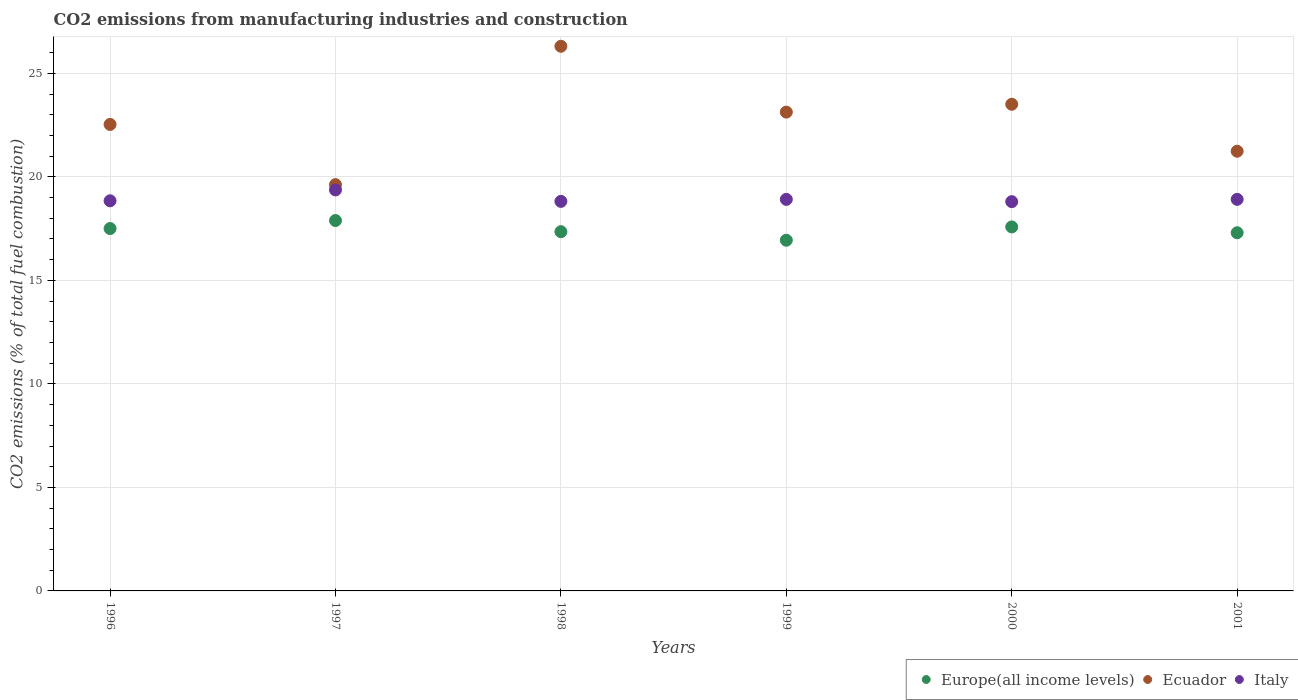How many different coloured dotlines are there?
Offer a very short reply. 3. Is the number of dotlines equal to the number of legend labels?
Offer a terse response. Yes. What is the amount of CO2 emitted in Ecuador in 2000?
Give a very brief answer. 23.51. Across all years, what is the maximum amount of CO2 emitted in Ecuador?
Your response must be concise. 26.31. Across all years, what is the minimum amount of CO2 emitted in Europe(all income levels)?
Ensure brevity in your answer.  16.94. In which year was the amount of CO2 emitted in Ecuador minimum?
Ensure brevity in your answer.  1997. What is the total amount of CO2 emitted in Ecuador in the graph?
Your response must be concise. 136.35. What is the difference between the amount of CO2 emitted in Italy in 1997 and that in 1998?
Provide a succinct answer. 0.55. What is the difference between the amount of CO2 emitted in Europe(all income levels) in 1998 and the amount of CO2 emitted in Ecuador in 1997?
Your answer should be very brief. -2.27. What is the average amount of CO2 emitted in Europe(all income levels) per year?
Provide a succinct answer. 17.43. In the year 1997, what is the difference between the amount of CO2 emitted in Europe(all income levels) and amount of CO2 emitted in Ecuador?
Provide a succinct answer. -1.74. What is the ratio of the amount of CO2 emitted in Europe(all income levels) in 1997 to that in 2000?
Provide a short and direct response. 1.02. What is the difference between the highest and the second highest amount of CO2 emitted in Europe(all income levels)?
Offer a very short reply. 0.31. What is the difference between the highest and the lowest amount of CO2 emitted in Italy?
Provide a succinct answer. 0.57. Is it the case that in every year, the sum of the amount of CO2 emitted in Europe(all income levels) and amount of CO2 emitted in Italy  is greater than the amount of CO2 emitted in Ecuador?
Offer a terse response. Yes. Is the amount of CO2 emitted in Italy strictly less than the amount of CO2 emitted in Europe(all income levels) over the years?
Your answer should be very brief. No. What is the difference between two consecutive major ticks on the Y-axis?
Your response must be concise. 5. Does the graph contain any zero values?
Make the answer very short. No. How many legend labels are there?
Keep it short and to the point. 3. What is the title of the graph?
Give a very brief answer. CO2 emissions from manufacturing industries and construction. What is the label or title of the X-axis?
Provide a succinct answer. Years. What is the label or title of the Y-axis?
Your response must be concise. CO2 emissions (% of total fuel combustion). What is the CO2 emissions (% of total fuel combustion) in Europe(all income levels) in 1996?
Give a very brief answer. 17.51. What is the CO2 emissions (% of total fuel combustion) in Ecuador in 1996?
Your response must be concise. 22.53. What is the CO2 emissions (% of total fuel combustion) of Italy in 1996?
Your response must be concise. 18.84. What is the CO2 emissions (% of total fuel combustion) of Europe(all income levels) in 1997?
Ensure brevity in your answer.  17.89. What is the CO2 emissions (% of total fuel combustion) of Ecuador in 1997?
Offer a very short reply. 19.63. What is the CO2 emissions (% of total fuel combustion) of Italy in 1997?
Your answer should be compact. 19.37. What is the CO2 emissions (% of total fuel combustion) in Europe(all income levels) in 1998?
Offer a very short reply. 17.35. What is the CO2 emissions (% of total fuel combustion) in Ecuador in 1998?
Your answer should be compact. 26.31. What is the CO2 emissions (% of total fuel combustion) in Italy in 1998?
Your answer should be very brief. 18.82. What is the CO2 emissions (% of total fuel combustion) in Europe(all income levels) in 1999?
Provide a succinct answer. 16.94. What is the CO2 emissions (% of total fuel combustion) of Ecuador in 1999?
Your response must be concise. 23.13. What is the CO2 emissions (% of total fuel combustion) of Italy in 1999?
Ensure brevity in your answer.  18.91. What is the CO2 emissions (% of total fuel combustion) of Europe(all income levels) in 2000?
Keep it short and to the point. 17.58. What is the CO2 emissions (% of total fuel combustion) of Ecuador in 2000?
Ensure brevity in your answer.  23.51. What is the CO2 emissions (% of total fuel combustion) in Italy in 2000?
Your answer should be very brief. 18.8. What is the CO2 emissions (% of total fuel combustion) in Europe(all income levels) in 2001?
Make the answer very short. 17.3. What is the CO2 emissions (% of total fuel combustion) of Ecuador in 2001?
Offer a terse response. 21.24. What is the CO2 emissions (% of total fuel combustion) in Italy in 2001?
Your response must be concise. 18.91. Across all years, what is the maximum CO2 emissions (% of total fuel combustion) of Europe(all income levels)?
Provide a succinct answer. 17.89. Across all years, what is the maximum CO2 emissions (% of total fuel combustion) in Ecuador?
Provide a succinct answer. 26.31. Across all years, what is the maximum CO2 emissions (% of total fuel combustion) of Italy?
Give a very brief answer. 19.37. Across all years, what is the minimum CO2 emissions (% of total fuel combustion) in Europe(all income levels)?
Offer a terse response. 16.94. Across all years, what is the minimum CO2 emissions (% of total fuel combustion) of Ecuador?
Offer a terse response. 19.63. Across all years, what is the minimum CO2 emissions (% of total fuel combustion) in Italy?
Your answer should be very brief. 18.8. What is the total CO2 emissions (% of total fuel combustion) of Europe(all income levels) in the graph?
Make the answer very short. 104.57. What is the total CO2 emissions (% of total fuel combustion) of Ecuador in the graph?
Make the answer very short. 136.35. What is the total CO2 emissions (% of total fuel combustion) in Italy in the graph?
Offer a very short reply. 113.66. What is the difference between the CO2 emissions (% of total fuel combustion) of Europe(all income levels) in 1996 and that in 1997?
Your response must be concise. -0.39. What is the difference between the CO2 emissions (% of total fuel combustion) in Ecuador in 1996 and that in 1997?
Offer a very short reply. 2.91. What is the difference between the CO2 emissions (% of total fuel combustion) in Italy in 1996 and that in 1997?
Your answer should be compact. -0.52. What is the difference between the CO2 emissions (% of total fuel combustion) of Europe(all income levels) in 1996 and that in 1998?
Make the answer very short. 0.15. What is the difference between the CO2 emissions (% of total fuel combustion) in Ecuador in 1996 and that in 1998?
Offer a very short reply. -3.78. What is the difference between the CO2 emissions (% of total fuel combustion) of Italy in 1996 and that in 1998?
Give a very brief answer. 0.03. What is the difference between the CO2 emissions (% of total fuel combustion) of Europe(all income levels) in 1996 and that in 1999?
Keep it short and to the point. 0.56. What is the difference between the CO2 emissions (% of total fuel combustion) of Ecuador in 1996 and that in 1999?
Ensure brevity in your answer.  -0.6. What is the difference between the CO2 emissions (% of total fuel combustion) in Italy in 1996 and that in 1999?
Your response must be concise. -0.07. What is the difference between the CO2 emissions (% of total fuel combustion) of Europe(all income levels) in 1996 and that in 2000?
Give a very brief answer. -0.08. What is the difference between the CO2 emissions (% of total fuel combustion) of Ecuador in 1996 and that in 2000?
Keep it short and to the point. -0.97. What is the difference between the CO2 emissions (% of total fuel combustion) in Italy in 1996 and that in 2000?
Give a very brief answer. 0.04. What is the difference between the CO2 emissions (% of total fuel combustion) of Europe(all income levels) in 1996 and that in 2001?
Ensure brevity in your answer.  0.2. What is the difference between the CO2 emissions (% of total fuel combustion) of Ecuador in 1996 and that in 2001?
Make the answer very short. 1.29. What is the difference between the CO2 emissions (% of total fuel combustion) in Italy in 1996 and that in 2001?
Your answer should be compact. -0.07. What is the difference between the CO2 emissions (% of total fuel combustion) of Europe(all income levels) in 1997 and that in 1998?
Provide a short and direct response. 0.54. What is the difference between the CO2 emissions (% of total fuel combustion) of Ecuador in 1997 and that in 1998?
Your answer should be very brief. -6.68. What is the difference between the CO2 emissions (% of total fuel combustion) in Italy in 1997 and that in 1998?
Your response must be concise. 0.55. What is the difference between the CO2 emissions (% of total fuel combustion) in Europe(all income levels) in 1997 and that in 1999?
Offer a terse response. 0.95. What is the difference between the CO2 emissions (% of total fuel combustion) in Ecuador in 1997 and that in 1999?
Your response must be concise. -3.5. What is the difference between the CO2 emissions (% of total fuel combustion) in Italy in 1997 and that in 1999?
Offer a terse response. 0.46. What is the difference between the CO2 emissions (% of total fuel combustion) in Europe(all income levels) in 1997 and that in 2000?
Your response must be concise. 0.31. What is the difference between the CO2 emissions (% of total fuel combustion) in Ecuador in 1997 and that in 2000?
Your response must be concise. -3.88. What is the difference between the CO2 emissions (% of total fuel combustion) of Italy in 1997 and that in 2000?
Offer a very short reply. 0.57. What is the difference between the CO2 emissions (% of total fuel combustion) of Europe(all income levels) in 1997 and that in 2001?
Your response must be concise. 0.59. What is the difference between the CO2 emissions (% of total fuel combustion) in Ecuador in 1997 and that in 2001?
Give a very brief answer. -1.61. What is the difference between the CO2 emissions (% of total fuel combustion) of Italy in 1997 and that in 2001?
Offer a terse response. 0.46. What is the difference between the CO2 emissions (% of total fuel combustion) of Europe(all income levels) in 1998 and that in 1999?
Give a very brief answer. 0.41. What is the difference between the CO2 emissions (% of total fuel combustion) of Ecuador in 1998 and that in 1999?
Your answer should be very brief. 3.18. What is the difference between the CO2 emissions (% of total fuel combustion) of Italy in 1998 and that in 1999?
Offer a terse response. -0.1. What is the difference between the CO2 emissions (% of total fuel combustion) of Europe(all income levels) in 1998 and that in 2000?
Your answer should be compact. -0.23. What is the difference between the CO2 emissions (% of total fuel combustion) in Ecuador in 1998 and that in 2000?
Provide a short and direct response. 2.8. What is the difference between the CO2 emissions (% of total fuel combustion) of Italy in 1998 and that in 2000?
Provide a succinct answer. 0.01. What is the difference between the CO2 emissions (% of total fuel combustion) in Europe(all income levels) in 1998 and that in 2001?
Your response must be concise. 0.05. What is the difference between the CO2 emissions (% of total fuel combustion) of Ecuador in 1998 and that in 2001?
Keep it short and to the point. 5.07. What is the difference between the CO2 emissions (% of total fuel combustion) of Italy in 1998 and that in 2001?
Your answer should be very brief. -0.1. What is the difference between the CO2 emissions (% of total fuel combustion) of Europe(all income levels) in 1999 and that in 2000?
Offer a terse response. -0.64. What is the difference between the CO2 emissions (% of total fuel combustion) of Ecuador in 1999 and that in 2000?
Provide a succinct answer. -0.38. What is the difference between the CO2 emissions (% of total fuel combustion) in Italy in 1999 and that in 2000?
Offer a terse response. 0.11. What is the difference between the CO2 emissions (% of total fuel combustion) of Europe(all income levels) in 1999 and that in 2001?
Provide a short and direct response. -0.36. What is the difference between the CO2 emissions (% of total fuel combustion) in Ecuador in 1999 and that in 2001?
Ensure brevity in your answer.  1.89. What is the difference between the CO2 emissions (% of total fuel combustion) of Italy in 1999 and that in 2001?
Offer a very short reply. -0. What is the difference between the CO2 emissions (% of total fuel combustion) of Europe(all income levels) in 2000 and that in 2001?
Give a very brief answer. 0.28. What is the difference between the CO2 emissions (% of total fuel combustion) of Ecuador in 2000 and that in 2001?
Make the answer very short. 2.27. What is the difference between the CO2 emissions (% of total fuel combustion) of Italy in 2000 and that in 2001?
Offer a very short reply. -0.11. What is the difference between the CO2 emissions (% of total fuel combustion) in Europe(all income levels) in 1996 and the CO2 emissions (% of total fuel combustion) in Ecuador in 1997?
Make the answer very short. -2.12. What is the difference between the CO2 emissions (% of total fuel combustion) of Europe(all income levels) in 1996 and the CO2 emissions (% of total fuel combustion) of Italy in 1997?
Ensure brevity in your answer.  -1.86. What is the difference between the CO2 emissions (% of total fuel combustion) in Ecuador in 1996 and the CO2 emissions (% of total fuel combustion) in Italy in 1997?
Provide a short and direct response. 3.16. What is the difference between the CO2 emissions (% of total fuel combustion) in Europe(all income levels) in 1996 and the CO2 emissions (% of total fuel combustion) in Ecuador in 1998?
Your answer should be compact. -8.8. What is the difference between the CO2 emissions (% of total fuel combustion) in Europe(all income levels) in 1996 and the CO2 emissions (% of total fuel combustion) in Italy in 1998?
Give a very brief answer. -1.31. What is the difference between the CO2 emissions (% of total fuel combustion) of Ecuador in 1996 and the CO2 emissions (% of total fuel combustion) of Italy in 1998?
Your answer should be compact. 3.72. What is the difference between the CO2 emissions (% of total fuel combustion) of Europe(all income levels) in 1996 and the CO2 emissions (% of total fuel combustion) of Ecuador in 1999?
Your answer should be compact. -5.62. What is the difference between the CO2 emissions (% of total fuel combustion) in Europe(all income levels) in 1996 and the CO2 emissions (% of total fuel combustion) in Italy in 1999?
Your answer should be very brief. -1.41. What is the difference between the CO2 emissions (% of total fuel combustion) in Ecuador in 1996 and the CO2 emissions (% of total fuel combustion) in Italy in 1999?
Your answer should be compact. 3.62. What is the difference between the CO2 emissions (% of total fuel combustion) in Europe(all income levels) in 1996 and the CO2 emissions (% of total fuel combustion) in Ecuador in 2000?
Offer a terse response. -6. What is the difference between the CO2 emissions (% of total fuel combustion) of Europe(all income levels) in 1996 and the CO2 emissions (% of total fuel combustion) of Italy in 2000?
Offer a terse response. -1.3. What is the difference between the CO2 emissions (% of total fuel combustion) of Ecuador in 1996 and the CO2 emissions (% of total fuel combustion) of Italy in 2000?
Keep it short and to the point. 3.73. What is the difference between the CO2 emissions (% of total fuel combustion) of Europe(all income levels) in 1996 and the CO2 emissions (% of total fuel combustion) of Ecuador in 2001?
Provide a short and direct response. -3.73. What is the difference between the CO2 emissions (% of total fuel combustion) of Europe(all income levels) in 1996 and the CO2 emissions (% of total fuel combustion) of Italy in 2001?
Your response must be concise. -1.41. What is the difference between the CO2 emissions (% of total fuel combustion) in Ecuador in 1996 and the CO2 emissions (% of total fuel combustion) in Italy in 2001?
Give a very brief answer. 3.62. What is the difference between the CO2 emissions (% of total fuel combustion) of Europe(all income levels) in 1997 and the CO2 emissions (% of total fuel combustion) of Ecuador in 1998?
Offer a terse response. -8.42. What is the difference between the CO2 emissions (% of total fuel combustion) in Europe(all income levels) in 1997 and the CO2 emissions (% of total fuel combustion) in Italy in 1998?
Ensure brevity in your answer.  -0.93. What is the difference between the CO2 emissions (% of total fuel combustion) in Ecuador in 1997 and the CO2 emissions (% of total fuel combustion) in Italy in 1998?
Offer a very short reply. 0.81. What is the difference between the CO2 emissions (% of total fuel combustion) in Europe(all income levels) in 1997 and the CO2 emissions (% of total fuel combustion) in Ecuador in 1999?
Give a very brief answer. -5.24. What is the difference between the CO2 emissions (% of total fuel combustion) in Europe(all income levels) in 1997 and the CO2 emissions (% of total fuel combustion) in Italy in 1999?
Provide a short and direct response. -1.02. What is the difference between the CO2 emissions (% of total fuel combustion) of Ecuador in 1997 and the CO2 emissions (% of total fuel combustion) of Italy in 1999?
Ensure brevity in your answer.  0.71. What is the difference between the CO2 emissions (% of total fuel combustion) in Europe(all income levels) in 1997 and the CO2 emissions (% of total fuel combustion) in Ecuador in 2000?
Make the answer very short. -5.62. What is the difference between the CO2 emissions (% of total fuel combustion) of Europe(all income levels) in 1997 and the CO2 emissions (% of total fuel combustion) of Italy in 2000?
Your answer should be compact. -0.91. What is the difference between the CO2 emissions (% of total fuel combustion) of Ecuador in 1997 and the CO2 emissions (% of total fuel combustion) of Italy in 2000?
Your response must be concise. 0.82. What is the difference between the CO2 emissions (% of total fuel combustion) of Europe(all income levels) in 1997 and the CO2 emissions (% of total fuel combustion) of Ecuador in 2001?
Your answer should be very brief. -3.35. What is the difference between the CO2 emissions (% of total fuel combustion) of Europe(all income levels) in 1997 and the CO2 emissions (% of total fuel combustion) of Italy in 2001?
Make the answer very short. -1.02. What is the difference between the CO2 emissions (% of total fuel combustion) in Ecuador in 1997 and the CO2 emissions (% of total fuel combustion) in Italy in 2001?
Provide a short and direct response. 0.71. What is the difference between the CO2 emissions (% of total fuel combustion) in Europe(all income levels) in 1998 and the CO2 emissions (% of total fuel combustion) in Ecuador in 1999?
Provide a succinct answer. -5.78. What is the difference between the CO2 emissions (% of total fuel combustion) of Europe(all income levels) in 1998 and the CO2 emissions (% of total fuel combustion) of Italy in 1999?
Keep it short and to the point. -1.56. What is the difference between the CO2 emissions (% of total fuel combustion) of Ecuador in 1998 and the CO2 emissions (% of total fuel combustion) of Italy in 1999?
Keep it short and to the point. 7.4. What is the difference between the CO2 emissions (% of total fuel combustion) of Europe(all income levels) in 1998 and the CO2 emissions (% of total fuel combustion) of Ecuador in 2000?
Your answer should be compact. -6.16. What is the difference between the CO2 emissions (% of total fuel combustion) of Europe(all income levels) in 1998 and the CO2 emissions (% of total fuel combustion) of Italy in 2000?
Your answer should be very brief. -1.45. What is the difference between the CO2 emissions (% of total fuel combustion) of Ecuador in 1998 and the CO2 emissions (% of total fuel combustion) of Italy in 2000?
Your response must be concise. 7.51. What is the difference between the CO2 emissions (% of total fuel combustion) in Europe(all income levels) in 1998 and the CO2 emissions (% of total fuel combustion) in Ecuador in 2001?
Your response must be concise. -3.89. What is the difference between the CO2 emissions (% of total fuel combustion) of Europe(all income levels) in 1998 and the CO2 emissions (% of total fuel combustion) of Italy in 2001?
Make the answer very short. -1.56. What is the difference between the CO2 emissions (% of total fuel combustion) in Ecuador in 1998 and the CO2 emissions (% of total fuel combustion) in Italy in 2001?
Give a very brief answer. 7.39. What is the difference between the CO2 emissions (% of total fuel combustion) of Europe(all income levels) in 1999 and the CO2 emissions (% of total fuel combustion) of Ecuador in 2000?
Ensure brevity in your answer.  -6.57. What is the difference between the CO2 emissions (% of total fuel combustion) in Europe(all income levels) in 1999 and the CO2 emissions (% of total fuel combustion) in Italy in 2000?
Offer a very short reply. -1.86. What is the difference between the CO2 emissions (% of total fuel combustion) in Ecuador in 1999 and the CO2 emissions (% of total fuel combustion) in Italy in 2000?
Your answer should be compact. 4.33. What is the difference between the CO2 emissions (% of total fuel combustion) of Europe(all income levels) in 1999 and the CO2 emissions (% of total fuel combustion) of Ecuador in 2001?
Offer a terse response. -4.3. What is the difference between the CO2 emissions (% of total fuel combustion) in Europe(all income levels) in 1999 and the CO2 emissions (% of total fuel combustion) in Italy in 2001?
Make the answer very short. -1.97. What is the difference between the CO2 emissions (% of total fuel combustion) in Ecuador in 1999 and the CO2 emissions (% of total fuel combustion) in Italy in 2001?
Your answer should be compact. 4.21. What is the difference between the CO2 emissions (% of total fuel combustion) of Europe(all income levels) in 2000 and the CO2 emissions (% of total fuel combustion) of Ecuador in 2001?
Your answer should be compact. -3.66. What is the difference between the CO2 emissions (% of total fuel combustion) of Europe(all income levels) in 2000 and the CO2 emissions (% of total fuel combustion) of Italy in 2001?
Ensure brevity in your answer.  -1.33. What is the difference between the CO2 emissions (% of total fuel combustion) of Ecuador in 2000 and the CO2 emissions (% of total fuel combustion) of Italy in 2001?
Give a very brief answer. 4.59. What is the average CO2 emissions (% of total fuel combustion) of Europe(all income levels) per year?
Provide a succinct answer. 17.43. What is the average CO2 emissions (% of total fuel combustion) of Ecuador per year?
Offer a terse response. 22.72. What is the average CO2 emissions (% of total fuel combustion) of Italy per year?
Offer a very short reply. 18.94. In the year 1996, what is the difference between the CO2 emissions (% of total fuel combustion) of Europe(all income levels) and CO2 emissions (% of total fuel combustion) of Ecuador?
Your answer should be very brief. -5.03. In the year 1996, what is the difference between the CO2 emissions (% of total fuel combustion) in Europe(all income levels) and CO2 emissions (% of total fuel combustion) in Italy?
Your response must be concise. -1.34. In the year 1996, what is the difference between the CO2 emissions (% of total fuel combustion) in Ecuador and CO2 emissions (% of total fuel combustion) in Italy?
Your answer should be very brief. 3.69. In the year 1997, what is the difference between the CO2 emissions (% of total fuel combustion) of Europe(all income levels) and CO2 emissions (% of total fuel combustion) of Ecuador?
Provide a short and direct response. -1.74. In the year 1997, what is the difference between the CO2 emissions (% of total fuel combustion) in Europe(all income levels) and CO2 emissions (% of total fuel combustion) in Italy?
Give a very brief answer. -1.48. In the year 1997, what is the difference between the CO2 emissions (% of total fuel combustion) of Ecuador and CO2 emissions (% of total fuel combustion) of Italy?
Make the answer very short. 0.26. In the year 1998, what is the difference between the CO2 emissions (% of total fuel combustion) in Europe(all income levels) and CO2 emissions (% of total fuel combustion) in Ecuador?
Your answer should be compact. -8.96. In the year 1998, what is the difference between the CO2 emissions (% of total fuel combustion) in Europe(all income levels) and CO2 emissions (% of total fuel combustion) in Italy?
Provide a succinct answer. -1.46. In the year 1998, what is the difference between the CO2 emissions (% of total fuel combustion) in Ecuador and CO2 emissions (% of total fuel combustion) in Italy?
Offer a very short reply. 7.49. In the year 1999, what is the difference between the CO2 emissions (% of total fuel combustion) in Europe(all income levels) and CO2 emissions (% of total fuel combustion) in Ecuador?
Your answer should be compact. -6.19. In the year 1999, what is the difference between the CO2 emissions (% of total fuel combustion) in Europe(all income levels) and CO2 emissions (% of total fuel combustion) in Italy?
Your answer should be very brief. -1.97. In the year 1999, what is the difference between the CO2 emissions (% of total fuel combustion) of Ecuador and CO2 emissions (% of total fuel combustion) of Italy?
Offer a terse response. 4.22. In the year 2000, what is the difference between the CO2 emissions (% of total fuel combustion) in Europe(all income levels) and CO2 emissions (% of total fuel combustion) in Ecuador?
Make the answer very short. -5.93. In the year 2000, what is the difference between the CO2 emissions (% of total fuel combustion) in Europe(all income levels) and CO2 emissions (% of total fuel combustion) in Italy?
Your answer should be compact. -1.22. In the year 2000, what is the difference between the CO2 emissions (% of total fuel combustion) in Ecuador and CO2 emissions (% of total fuel combustion) in Italy?
Give a very brief answer. 4.7. In the year 2001, what is the difference between the CO2 emissions (% of total fuel combustion) in Europe(all income levels) and CO2 emissions (% of total fuel combustion) in Ecuador?
Give a very brief answer. -3.94. In the year 2001, what is the difference between the CO2 emissions (% of total fuel combustion) of Europe(all income levels) and CO2 emissions (% of total fuel combustion) of Italy?
Offer a terse response. -1.61. In the year 2001, what is the difference between the CO2 emissions (% of total fuel combustion) in Ecuador and CO2 emissions (% of total fuel combustion) in Italy?
Your response must be concise. 2.32. What is the ratio of the CO2 emissions (% of total fuel combustion) of Europe(all income levels) in 1996 to that in 1997?
Offer a very short reply. 0.98. What is the ratio of the CO2 emissions (% of total fuel combustion) of Ecuador in 1996 to that in 1997?
Offer a very short reply. 1.15. What is the ratio of the CO2 emissions (% of total fuel combustion) of Italy in 1996 to that in 1997?
Your answer should be compact. 0.97. What is the ratio of the CO2 emissions (% of total fuel combustion) in Europe(all income levels) in 1996 to that in 1998?
Keep it short and to the point. 1.01. What is the ratio of the CO2 emissions (% of total fuel combustion) of Ecuador in 1996 to that in 1998?
Your answer should be very brief. 0.86. What is the ratio of the CO2 emissions (% of total fuel combustion) in Europe(all income levels) in 1996 to that in 1999?
Your answer should be compact. 1.03. What is the ratio of the CO2 emissions (% of total fuel combustion) in Ecuador in 1996 to that in 1999?
Provide a short and direct response. 0.97. What is the ratio of the CO2 emissions (% of total fuel combustion) in Ecuador in 1996 to that in 2000?
Your answer should be very brief. 0.96. What is the ratio of the CO2 emissions (% of total fuel combustion) in Europe(all income levels) in 1996 to that in 2001?
Ensure brevity in your answer.  1.01. What is the ratio of the CO2 emissions (% of total fuel combustion) in Ecuador in 1996 to that in 2001?
Keep it short and to the point. 1.06. What is the ratio of the CO2 emissions (% of total fuel combustion) in Italy in 1996 to that in 2001?
Offer a terse response. 1. What is the ratio of the CO2 emissions (% of total fuel combustion) of Europe(all income levels) in 1997 to that in 1998?
Keep it short and to the point. 1.03. What is the ratio of the CO2 emissions (% of total fuel combustion) in Ecuador in 1997 to that in 1998?
Your response must be concise. 0.75. What is the ratio of the CO2 emissions (% of total fuel combustion) of Italy in 1997 to that in 1998?
Keep it short and to the point. 1.03. What is the ratio of the CO2 emissions (% of total fuel combustion) of Europe(all income levels) in 1997 to that in 1999?
Your response must be concise. 1.06. What is the ratio of the CO2 emissions (% of total fuel combustion) of Ecuador in 1997 to that in 1999?
Give a very brief answer. 0.85. What is the ratio of the CO2 emissions (% of total fuel combustion) in Italy in 1997 to that in 1999?
Your answer should be very brief. 1.02. What is the ratio of the CO2 emissions (% of total fuel combustion) of Europe(all income levels) in 1997 to that in 2000?
Provide a succinct answer. 1.02. What is the ratio of the CO2 emissions (% of total fuel combustion) in Ecuador in 1997 to that in 2000?
Your answer should be very brief. 0.83. What is the ratio of the CO2 emissions (% of total fuel combustion) in Italy in 1997 to that in 2000?
Make the answer very short. 1.03. What is the ratio of the CO2 emissions (% of total fuel combustion) of Europe(all income levels) in 1997 to that in 2001?
Give a very brief answer. 1.03. What is the ratio of the CO2 emissions (% of total fuel combustion) of Ecuador in 1997 to that in 2001?
Provide a short and direct response. 0.92. What is the ratio of the CO2 emissions (% of total fuel combustion) of Italy in 1997 to that in 2001?
Offer a very short reply. 1.02. What is the ratio of the CO2 emissions (% of total fuel combustion) of Europe(all income levels) in 1998 to that in 1999?
Your answer should be compact. 1.02. What is the ratio of the CO2 emissions (% of total fuel combustion) of Ecuador in 1998 to that in 1999?
Keep it short and to the point. 1.14. What is the ratio of the CO2 emissions (% of total fuel combustion) in Europe(all income levels) in 1998 to that in 2000?
Provide a succinct answer. 0.99. What is the ratio of the CO2 emissions (% of total fuel combustion) of Ecuador in 1998 to that in 2000?
Provide a succinct answer. 1.12. What is the ratio of the CO2 emissions (% of total fuel combustion) of Italy in 1998 to that in 2000?
Your answer should be compact. 1. What is the ratio of the CO2 emissions (% of total fuel combustion) of Europe(all income levels) in 1998 to that in 2001?
Offer a terse response. 1. What is the ratio of the CO2 emissions (% of total fuel combustion) of Ecuador in 1998 to that in 2001?
Your answer should be compact. 1.24. What is the ratio of the CO2 emissions (% of total fuel combustion) in Europe(all income levels) in 1999 to that in 2000?
Give a very brief answer. 0.96. What is the ratio of the CO2 emissions (% of total fuel combustion) in Ecuador in 1999 to that in 2000?
Offer a very short reply. 0.98. What is the ratio of the CO2 emissions (% of total fuel combustion) of Europe(all income levels) in 1999 to that in 2001?
Make the answer very short. 0.98. What is the ratio of the CO2 emissions (% of total fuel combustion) of Ecuador in 1999 to that in 2001?
Keep it short and to the point. 1.09. What is the ratio of the CO2 emissions (% of total fuel combustion) of Italy in 1999 to that in 2001?
Make the answer very short. 1. What is the ratio of the CO2 emissions (% of total fuel combustion) of Europe(all income levels) in 2000 to that in 2001?
Your answer should be compact. 1.02. What is the ratio of the CO2 emissions (% of total fuel combustion) of Ecuador in 2000 to that in 2001?
Keep it short and to the point. 1.11. What is the ratio of the CO2 emissions (% of total fuel combustion) of Italy in 2000 to that in 2001?
Make the answer very short. 0.99. What is the difference between the highest and the second highest CO2 emissions (% of total fuel combustion) of Europe(all income levels)?
Offer a very short reply. 0.31. What is the difference between the highest and the second highest CO2 emissions (% of total fuel combustion) of Ecuador?
Give a very brief answer. 2.8. What is the difference between the highest and the second highest CO2 emissions (% of total fuel combustion) of Italy?
Provide a succinct answer. 0.46. What is the difference between the highest and the lowest CO2 emissions (% of total fuel combustion) in Europe(all income levels)?
Offer a very short reply. 0.95. What is the difference between the highest and the lowest CO2 emissions (% of total fuel combustion) of Ecuador?
Make the answer very short. 6.68. What is the difference between the highest and the lowest CO2 emissions (% of total fuel combustion) of Italy?
Offer a very short reply. 0.57. 